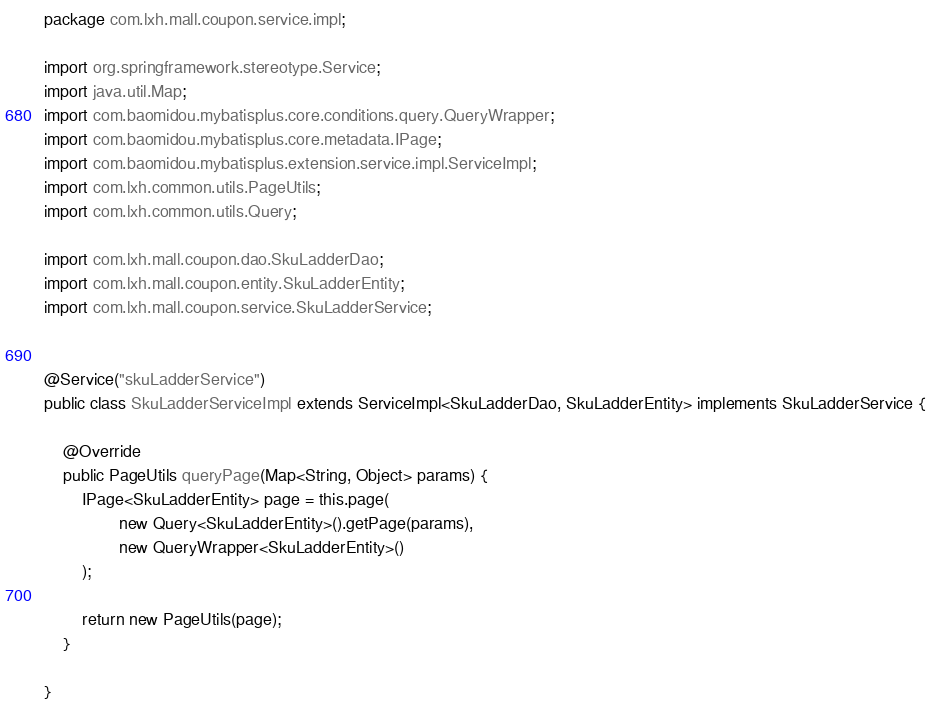Convert code to text. <code><loc_0><loc_0><loc_500><loc_500><_Java_>package com.lxh.mall.coupon.service.impl;

import org.springframework.stereotype.Service;
import java.util.Map;
import com.baomidou.mybatisplus.core.conditions.query.QueryWrapper;
import com.baomidou.mybatisplus.core.metadata.IPage;
import com.baomidou.mybatisplus.extension.service.impl.ServiceImpl;
import com.lxh.common.utils.PageUtils;
import com.lxh.common.utils.Query;

import com.lxh.mall.coupon.dao.SkuLadderDao;
import com.lxh.mall.coupon.entity.SkuLadderEntity;
import com.lxh.mall.coupon.service.SkuLadderService;


@Service("skuLadderService")
public class SkuLadderServiceImpl extends ServiceImpl<SkuLadderDao, SkuLadderEntity> implements SkuLadderService {

    @Override
    public PageUtils queryPage(Map<String, Object> params) {
        IPage<SkuLadderEntity> page = this.page(
                new Query<SkuLadderEntity>().getPage(params),
                new QueryWrapper<SkuLadderEntity>()
        );

        return new PageUtils(page);
    }

}</code> 